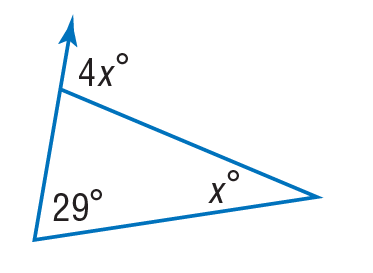Answer the mathemtical geometry problem and directly provide the correct option letter.
Question: Find x to the nearest tenth.
Choices: A: 5.8 B: 7.25 C: 9.67 D: 29 C 